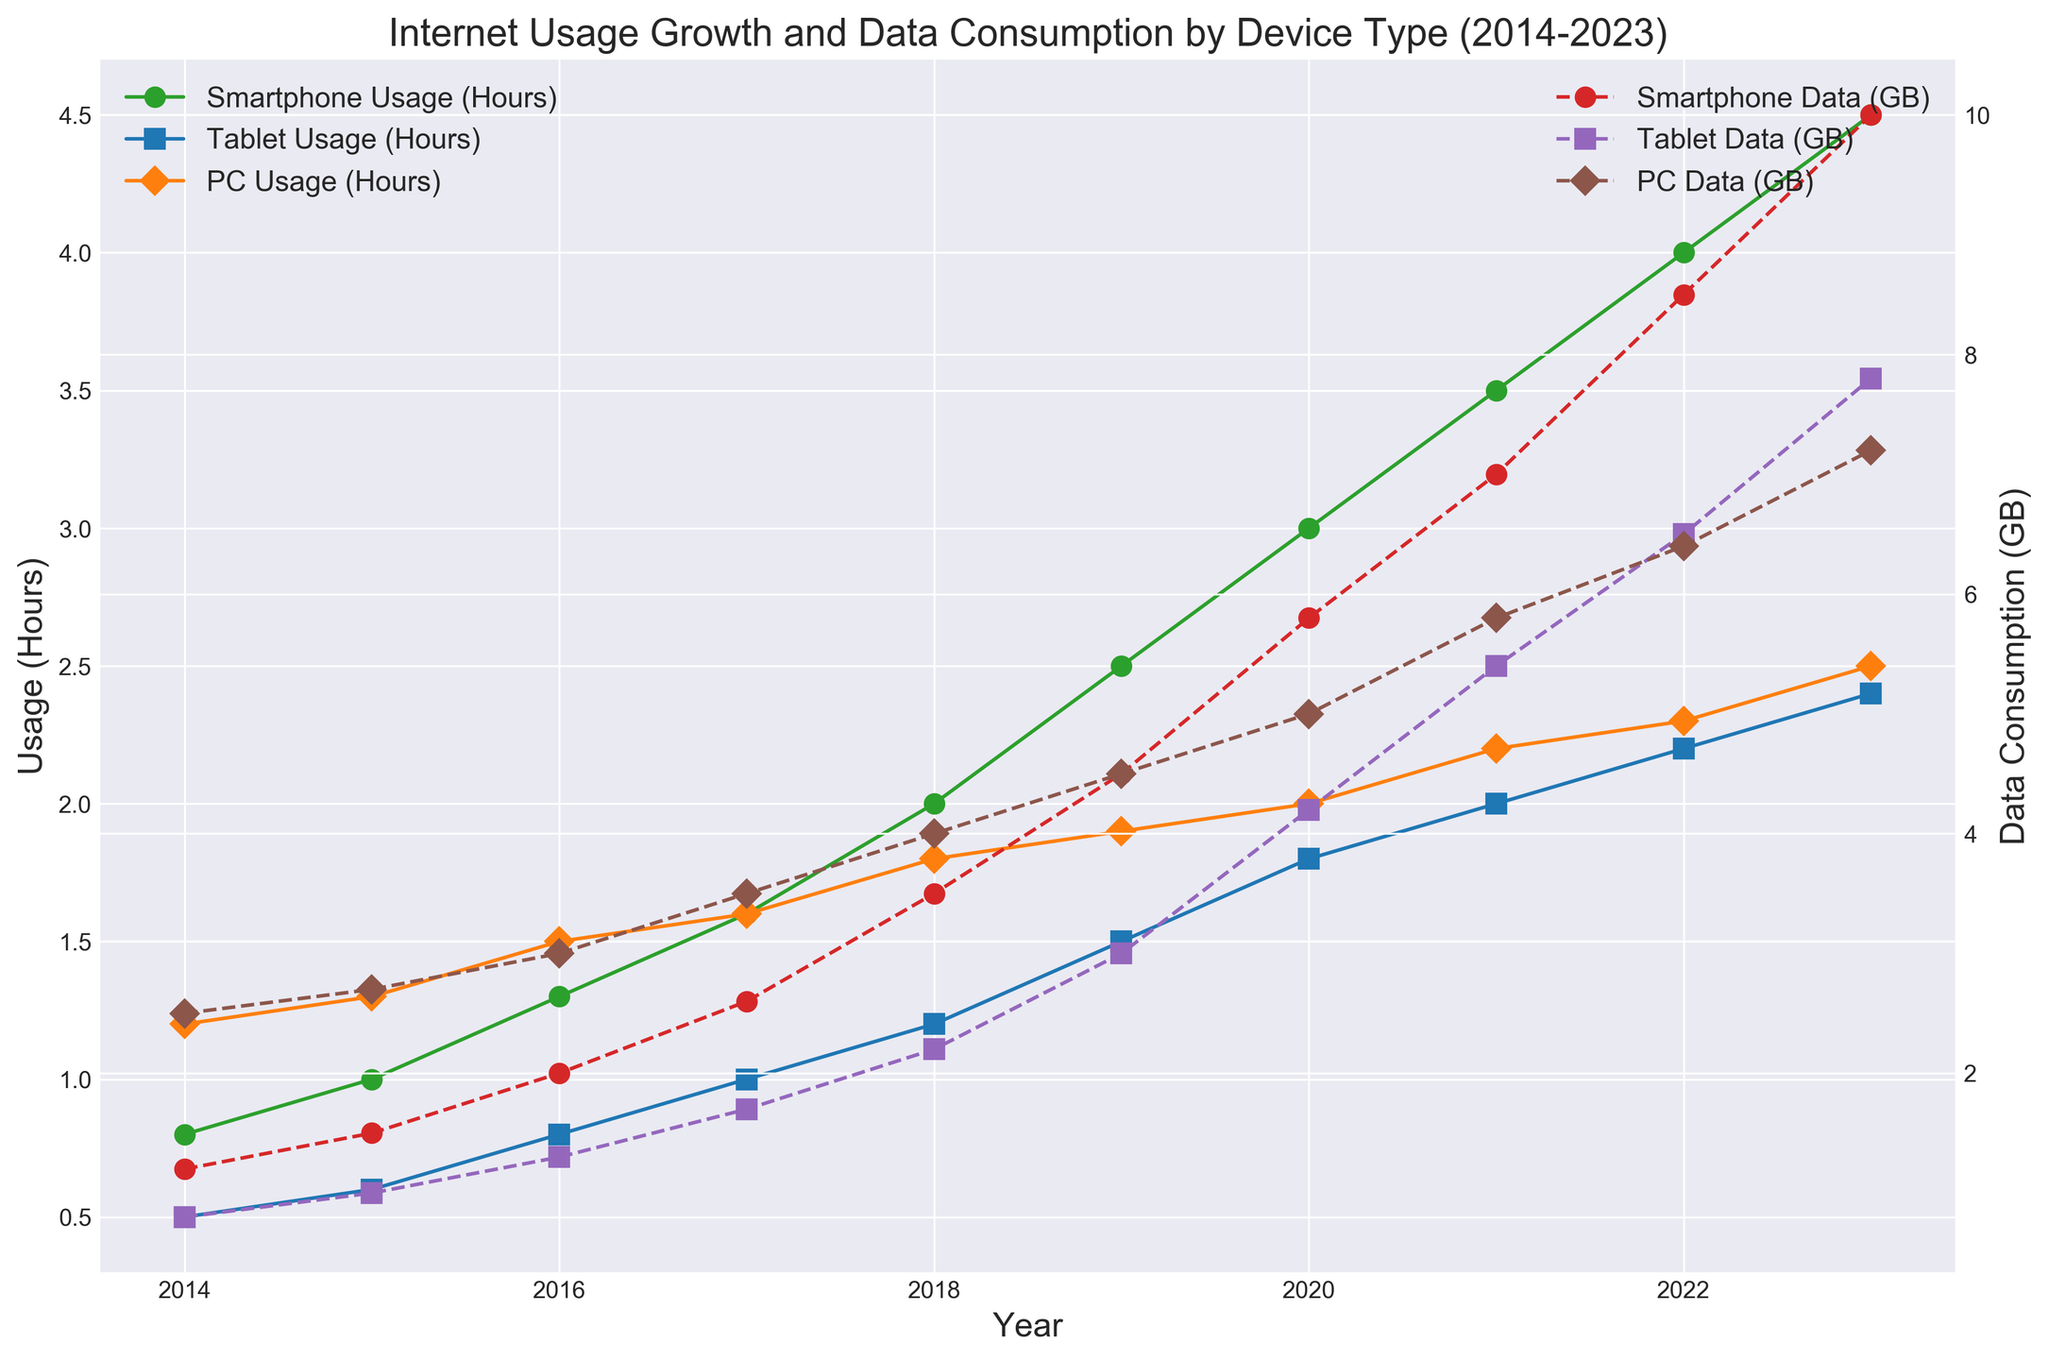What is the trend in smartphone usage hours from 2014 to 2023? To determine the trend, observe the line representing smartphone usage hours across the years. The green line with circle markers shows a gradual increase from 0.8 hours in 2014 to 4.5 hours in 2023.
Answer: Increasing Compare the data consumption of tablets and PCs in the year 2018. Which one is higher? Look at the data points for tablet and PC data consumption in 2018. The purple line with square markers (tablets) shows a consumption of 2.2 GB, and the brown line with diamond markers (PCs) shows 4.0 GB.
Answer: PCs What years did PC usage hours surpass 2 hours? Look at the orange line with diamond markers representing PC usage hours. It surpasses 2 hours in the years 2021 (2.2 hours), 2022 (2.3 hours), and 2023 (2.5 hours).
Answer: 2021, 2022, 2023 Calculate the average tablet usage hours for the years 2019 to 2023. Sum the tablet usage hours from 2019 (1.5), 2020 (1.8), 2021 (2.0), 2022 (2.2), and 2023 (2.4) and divide by 5. (1.5 + 1.8 + 2.0 + 2.2 + 2.4) / 5 = 9.9 / 5 = 1.98 hours.
Answer: 1.98 hours Which device type has the steepest increase in data consumption between 2019 and 2023? Compare the slopes of the data consumption lines (dashed lines) for smartphones, tablets, and PCs between these years. The red line with circle markers (smartphones) shows the largest increase from 4.5 GB to 10.0 GB.
Answer: Smartphones How does the increase in smartphone data consumption from 2015 to 2018 compare to the increase in tablet data consumption for the same period? The smartphone data consumption increases from 1.5 GB to 3.5 GB (2.0 GB increase), while tablet data consumption increases from 1.0 GB to 2.2 GB (1.2 GB increase).
Answer: Smartphone data consumption increased more What year saw the highest single-year increase in smartphone usage hours? Identify the year that shows the largest jump in smartphone usage hours on the green line with circle markers. The largest increase is from 2019 (2.5 hours) to 2020 (3.0 hours), a 0.5-hour increase.
Answer: 2020 What is the difference in PC data consumption between the years 2020 and 2023? Subtract the data consumption in 2020 (5.0 GB) from that in 2023 (7.2 GB). 7.2 GB - 5.0 GB = 2.2 GB.
Answer: 2.2 GB Identify the year in which tablet usage hours and PC usage hours are both equal to or greater than 2 hours. Both tablet and PC usage hours reach at least 2 hours in the year 2022 (2.2 hours for tablets and 2.3 hours for PCs).
Answer: 2022 